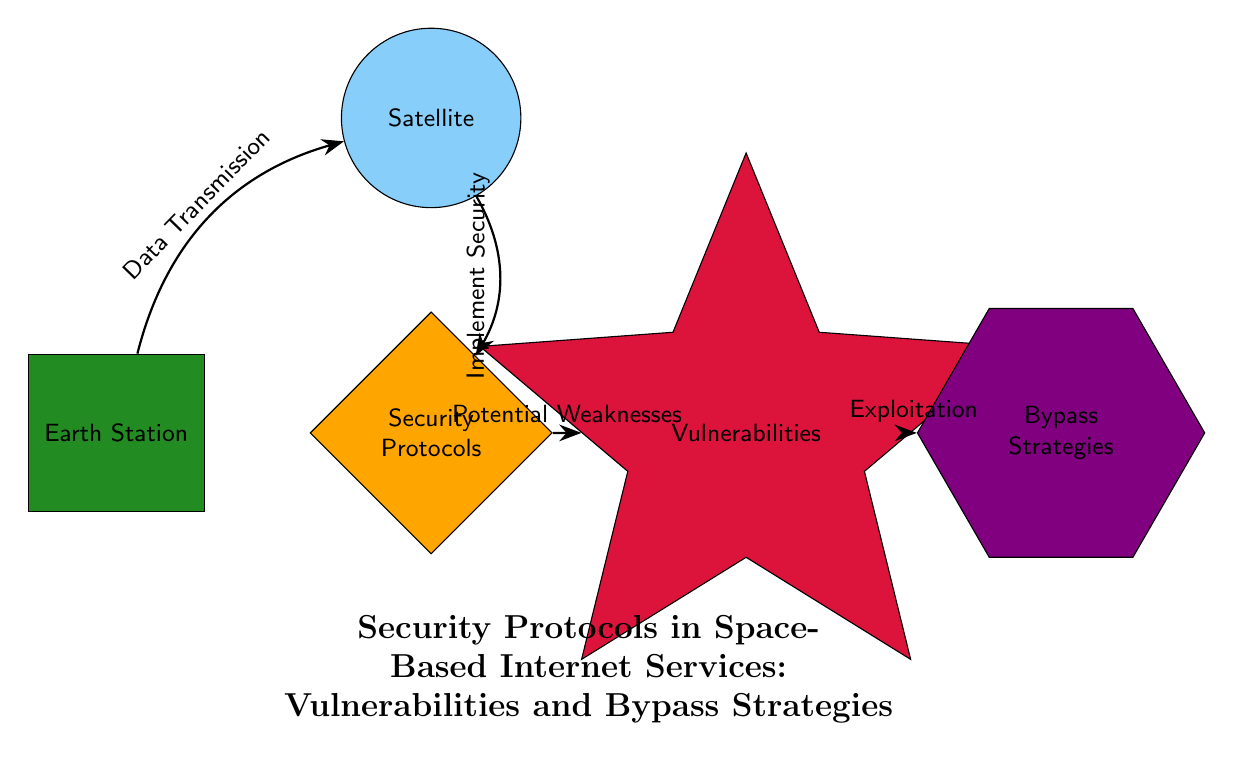What is the color representing the Earth Station? The diagram shows that the Earth Station is represented by a rectangle with the color fill defined as earthcolor, which is an RGB color of (34,139,34) or green.
Answer: green How many main nodes are there in the diagram? By counting the distinct shapes, there are five main nodes: Satellite, Earth Station, Security Protocols, Vulnerabilities, and Bypass Strategies.
Answer: five What type of node is the Security Protocols? The diagram indicates that Security Protocols is depicted as a diamond shape, which signifies its category among the main components.
Answer: diamond Which node follows Vulnerabilities in the flow of the diagram? Following the flow from Vulnerabilities, the next node is Bypass Strategies, indicating an exploitation progression from vulnerabilities.
Answer: Bypass Strategies What type of connection exists between Satellite and Security Protocols? The connection between Satellite and Security Protocols is an arrow that implies an action, specifically "Implement Security", indicating a direct flow from one to the other.
Answer: Implement Security What is the relationship between Security Protocols and Vulnerabilities? Security Protocols leads to Vulnerabilities with the relationship labeled as "Potential Weaknesses", suggesting that there are weaknesses inherent within the protocols.
Answer: Potential Weaknesses How many different node types are visualized in the diagram? The diagram includes four different node types: circle, rectangle, diamond, and star (along with a polygon), making for a total of four distinct types.
Answer: four What color represents the vulnerabilities in the diagram? Vulnerabilities are depicted in a star shape filled with the color defined as vulncolor, which is an RGB color of (220,20,60) or red.
Answer: red What action is indicated from Earth Station to Satellite? The arrow going from Earth Station to Satellite indicates "Data Transmission", which defines the flow of information from Earth to the satellite system.
Answer: Data Transmission 